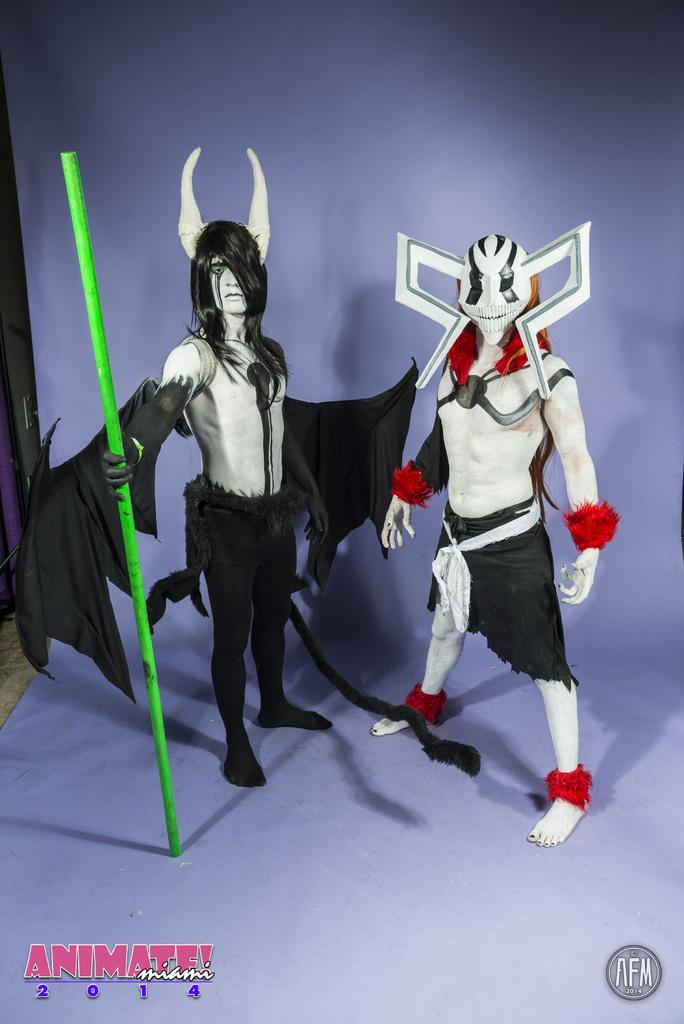How many people are present in the image? There are two people standing in the image. What are the people wearing? The people are wearing different costumes. What is one person holding in the image? One person is holding a stick. Can you describe any additional features of the image? There is a watermark at the bottom of the image. What type of leaf can be seen falling from the sky in the image? There is no leaf falling from the sky in the image. 